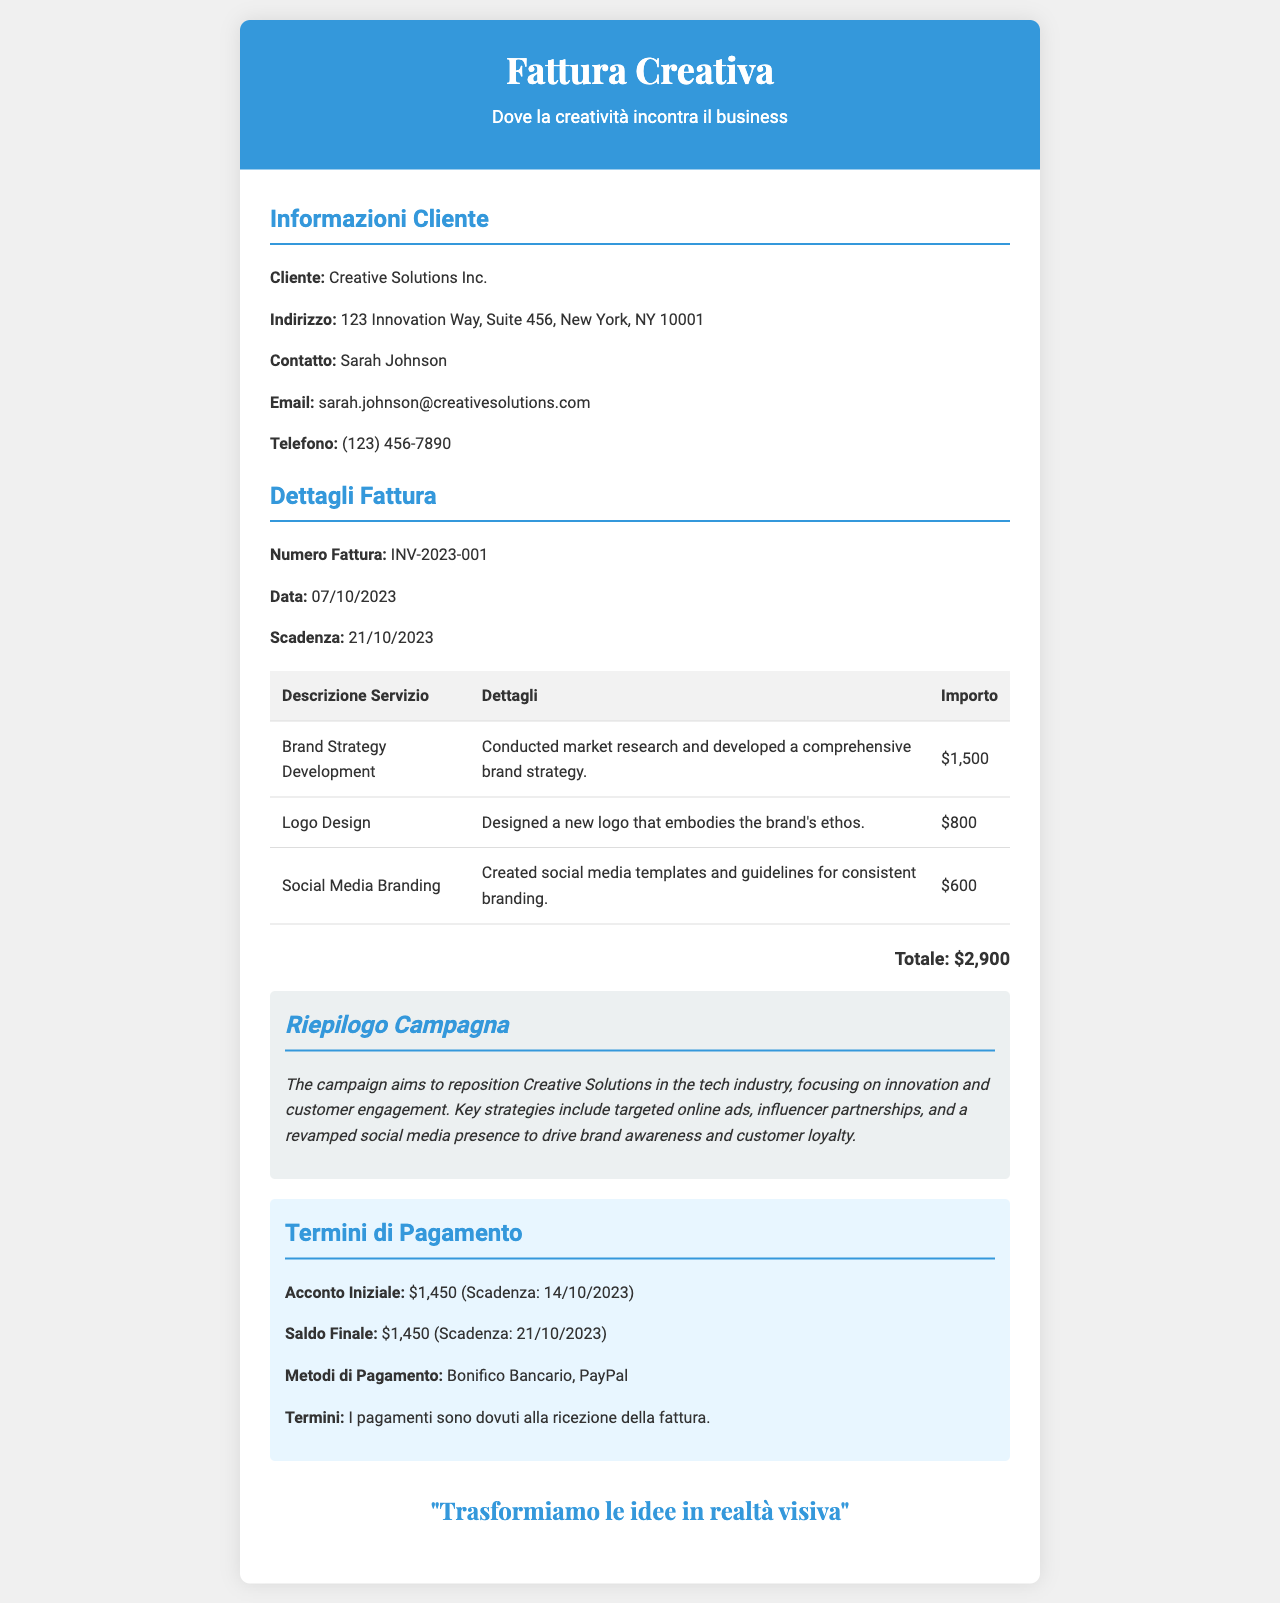what is the client's name? The client's name is listed under "Informazioni Cliente," which identifies the recipient of the invoice.
Answer: Creative Solutions Inc what is the invoice number? The invoice number is a unique identifier provided in the "Dettagli Fattura" section.
Answer: INV-2023-001 when is the payment due? The payment due date is specified in the "Dettagli Fattura" section.
Answer: 21/10/2023 what is the total amount of the invoice? The total amount is calculated by summing all provided service amounts in the invoice.
Answer: $2,900 what service costs $800? This service information is found in the table that details each individual service charge.
Answer: Logo Design what payment methods are accepted? These methods are explicitly listed under "Termini di Pagamento."
Answer: Bonifico Bancario, PayPal what is the purpose of the campaign? The purpose is summarized in the "Riepilogo Campagna" section, focusing on the brand's goals.
Answer: Reposition Creative Solutions in the tech industry how much is the initial deposit? The initial deposit figure is detailed in the "Termini di Pagamento" section.
Answer: $1,450 who is the contact person for the client? The contact person's name is provided in the "Informazioni Cliente" section for direct communication.
Answer: Sarah Johnson 